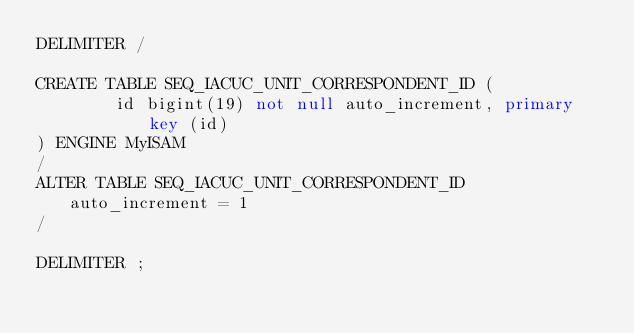<code> <loc_0><loc_0><loc_500><loc_500><_SQL_>DELIMITER /

CREATE TABLE SEQ_IACUC_UNIT_CORRESPONDENT_ID (
		id bigint(19) not null auto_increment, primary key (id)
) ENGINE MyISAM
/
ALTER TABLE SEQ_IACUC_UNIT_CORRESPONDENT_ID auto_increment = 1
/

DELIMITER ;
</code> 